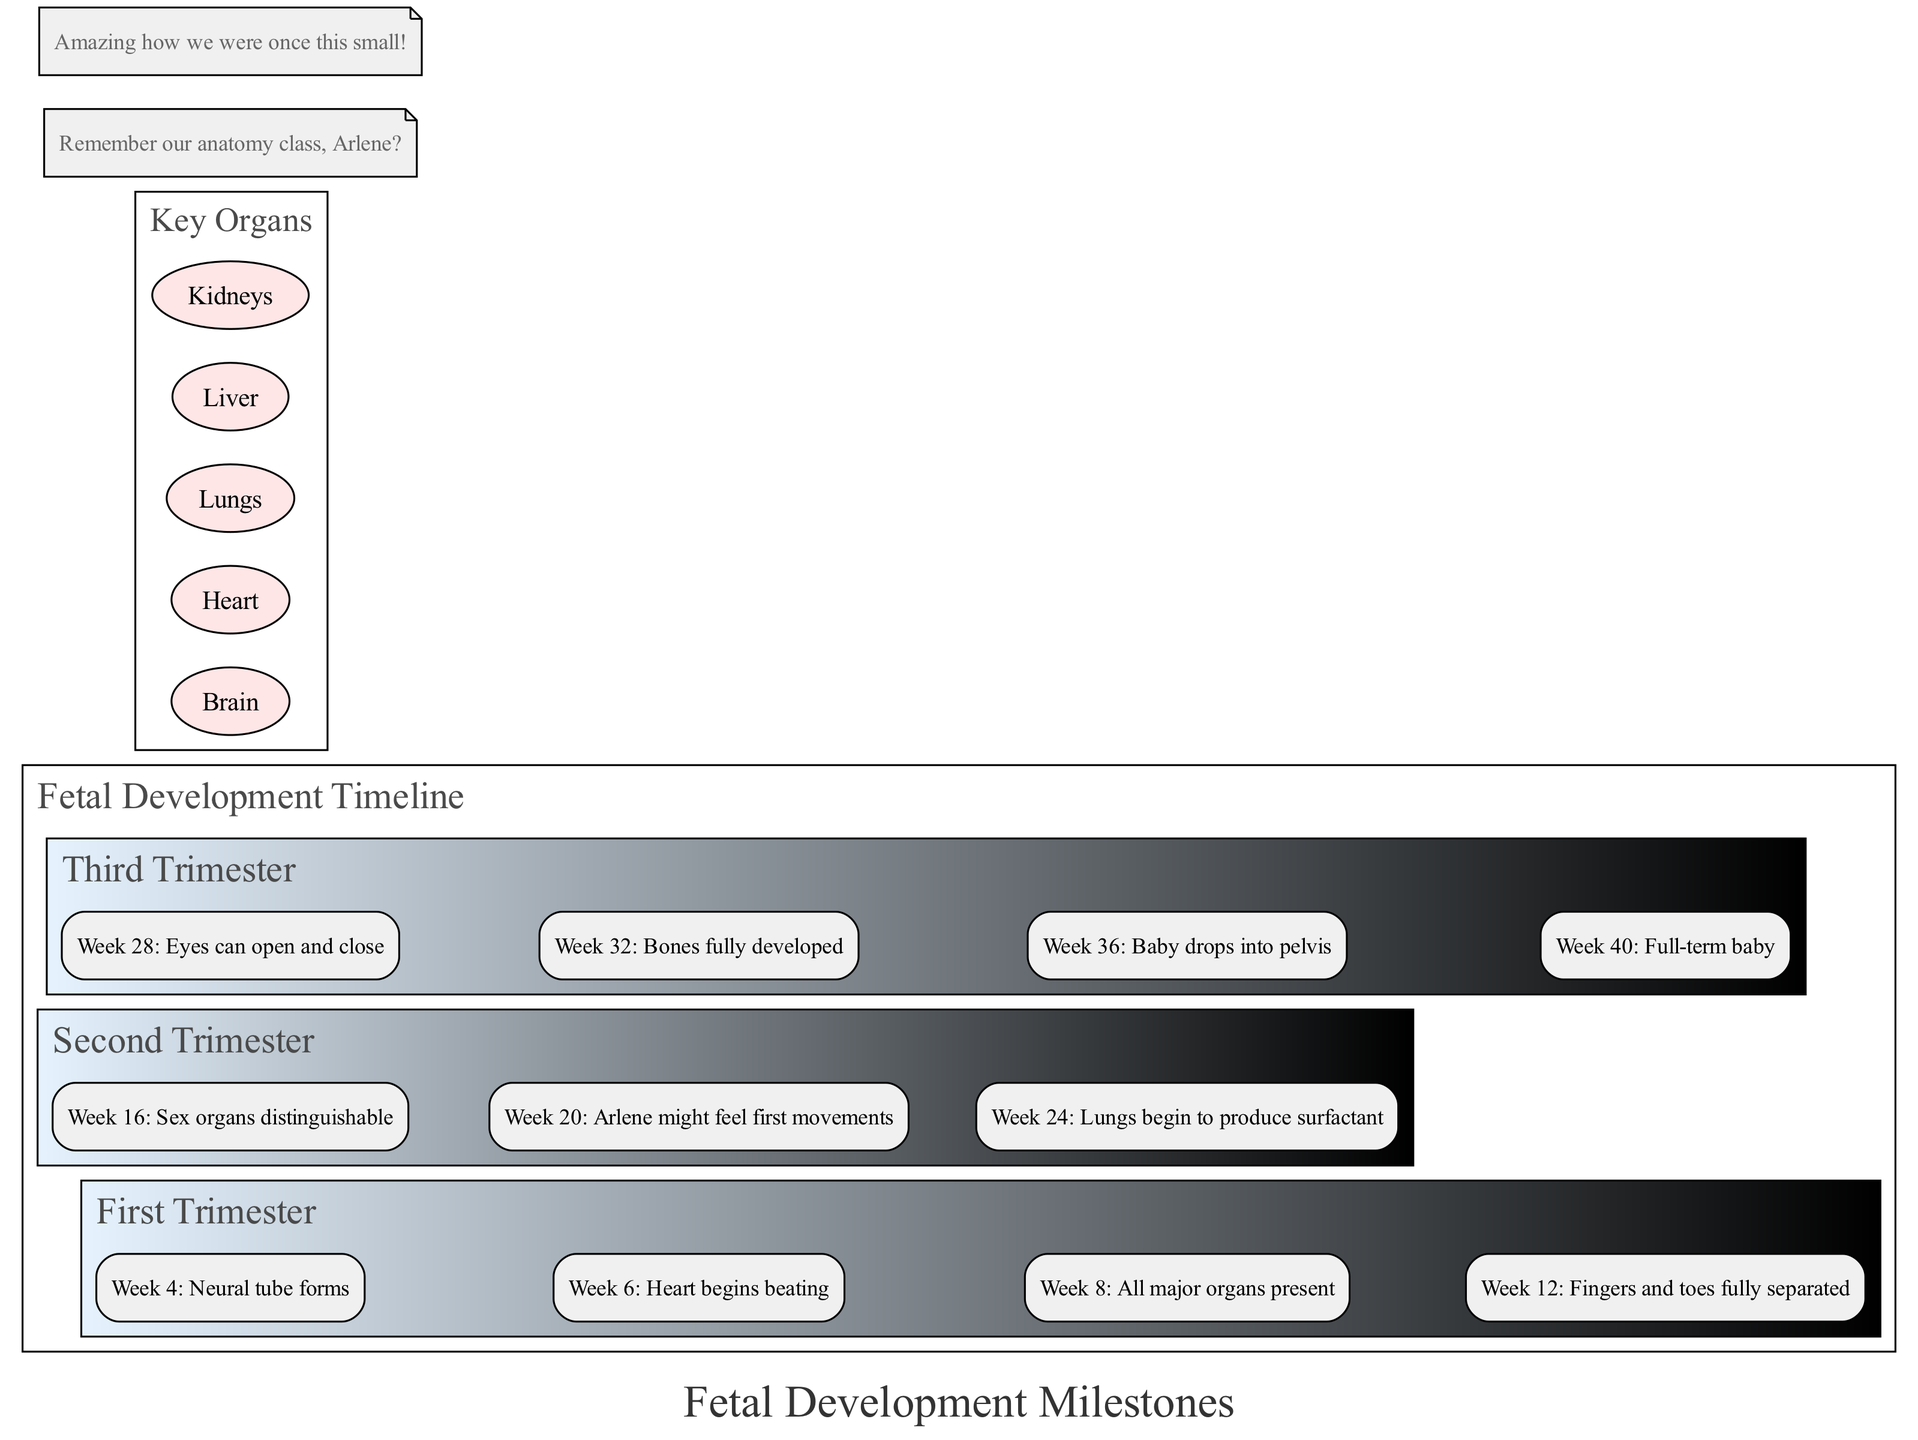What is the first milestone in the first trimester? According to the diagram, the first milestone listed under the first trimester is "Week 4: Neural tube forms." Therefore, we identify the milestone at week 4 as the first milestone.
Answer: Week 4: Neural tube forms How many milestones are there in the second trimester? The diagram shows three milestones listed under the second trimester: "Week 16: Sex organs distinguishable," "Week 20: Arlene might feel first movements," and "Week 24: Lungs begin to produce surfactant." Counting these gives a total of three milestones.
Answer: 3 What week does the heart begin to beat? In the diagram, it states that the heart begins beating at "Week 6." This is a specific milestone mentioned in the first trimester.
Answer: Week 6 At what stage can the baby’s sex organs be distinguished? From the diagram, the milestone indicating the distinguishable sex organs is at "Week 16," which is in the second trimester. Therefore, we can conclude that this change occurs at this specific week of development.
Answer: Week 16 What milestone occurs just before the baby drops into the pelvis? The milestone listed prior to the baby dropping into the pelvis (which happens at "Week 36") is "Week 32: Bones fully developed." By reviewing the milestones in the third trimester, we can confirm that bones develop fully before the baby drops.
Answer: Week 32: Bones fully developed Which organ starts producing surfactant, and at what week? The diagram indicates that the lungs begin to produce surfactant at "Week 24." Thus, by cross-referencing the specific milestone with the corresponding organ, we find that it is the lungs that perform this function during the specified week.
Answer: Lungs, Week 24 How many key organs are listed in the diagram? The diagram specifies five key organs: Brain, Heart, Lungs, Liver, and Kidneys. By counting these listed organs, we determine the total.
Answer: 5 